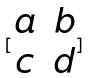<formula> <loc_0><loc_0><loc_500><loc_500>[ \begin{matrix} a & b \\ c & d \\ \end{matrix} ]</formula> 